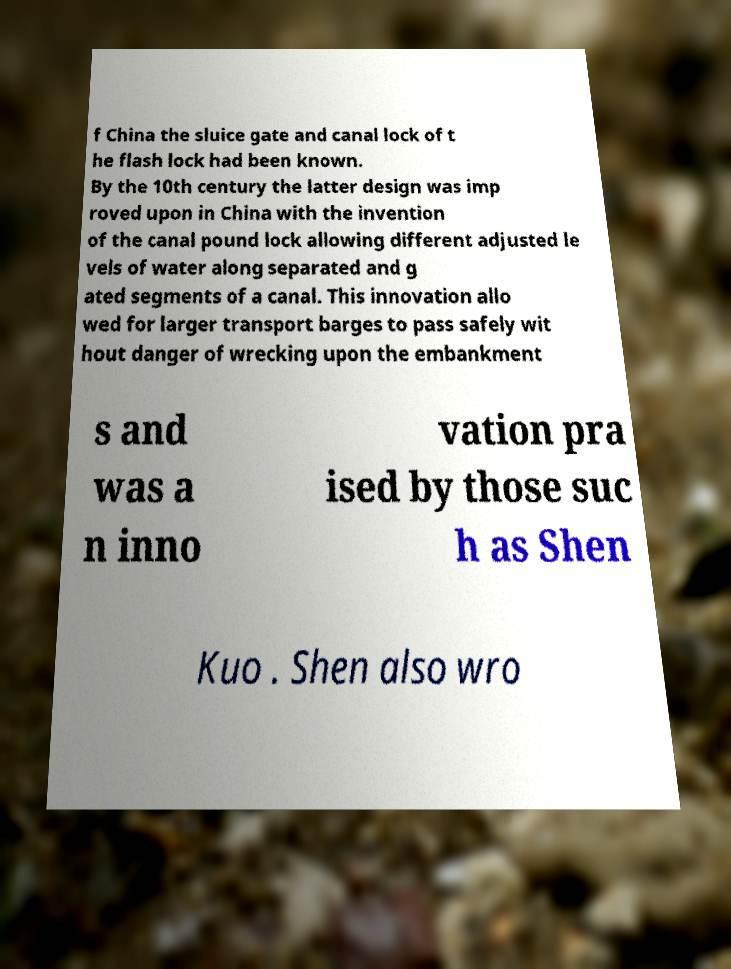Please read and relay the text visible in this image. What does it say? f China the sluice gate and canal lock of t he flash lock had been known. By the 10th century the latter design was imp roved upon in China with the invention of the canal pound lock allowing different adjusted le vels of water along separated and g ated segments of a canal. This innovation allo wed for larger transport barges to pass safely wit hout danger of wrecking upon the embankment s and was a n inno vation pra ised by those suc h as Shen Kuo . Shen also wro 